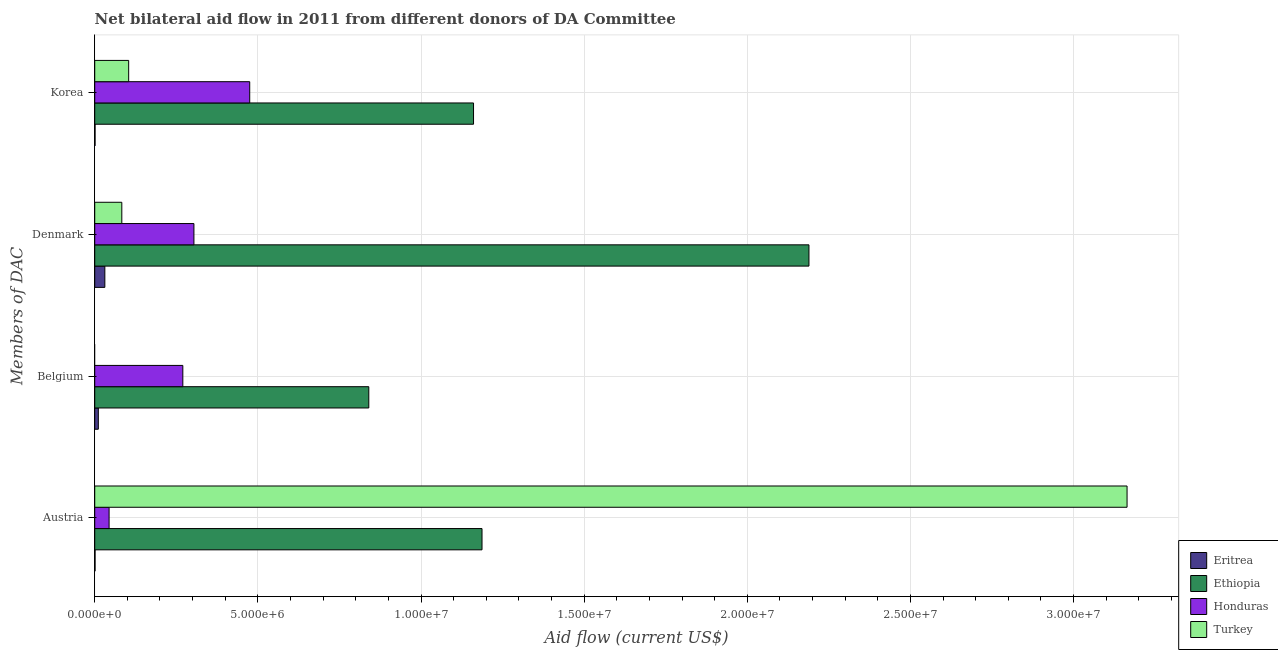How many different coloured bars are there?
Ensure brevity in your answer.  4. How many groups of bars are there?
Your answer should be compact. 4. Are the number of bars per tick equal to the number of legend labels?
Keep it short and to the point. No. How many bars are there on the 3rd tick from the bottom?
Keep it short and to the point. 4. What is the amount of aid given by austria in Eritrea?
Offer a terse response. 10000. Across all countries, what is the maximum amount of aid given by austria?
Your answer should be compact. 3.16e+07. Across all countries, what is the minimum amount of aid given by korea?
Keep it short and to the point. 10000. In which country was the amount of aid given by korea maximum?
Ensure brevity in your answer.  Ethiopia. What is the total amount of aid given by austria in the graph?
Provide a short and direct response. 4.40e+07. What is the difference between the amount of aid given by belgium in Ethiopia and that in Honduras?
Provide a succinct answer. 5.70e+06. What is the difference between the amount of aid given by belgium in Ethiopia and the amount of aid given by korea in Honduras?
Provide a short and direct response. 3.65e+06. What is the average amount of aid given by korea per country?
Make the answer very short. 4.35e+06. What is the difference between the amount of aid given by austria and amount of aid given by denmark in Ethiopia?
Your answer should be compact. -1.00e+07. What is the ratio of the amount of aid given by korea in Eritrea to that in Turkey?
Offer a very short reply. 0.01. Is the amount of aid given by korea in Eritrea less than that in Ethiopia?
Ensure brevity in your answer.  Yes. What is the difference between the highest and the second highest amount of aid given by austria?
Provide a short and direct response. 1.98e+07. What is the difference between the highest and the lowest amount of aid given by austria?
Your answer should be very brief. 3.16e+07. In how many countries, is the amount of aid given by korea greater than the average amount of aid given by korea taken over all countries?
Keep it short and to the point. 2. Is it the case that in every country, the sum of the amount of aid given by denmark and amount of aid given by belgium is greater than the sum of amount of aid given by austria and amount of aid given by korea?
Offer a terse response. No. Is it the case that in every country, the sum of the amount of aid given by austria and amount of aid given by belgium is greater than the amount of aid given by denmark?
Offer a terse response. No. How many countries are there in the graph?
Provide a short and direct response. 4. What is the difference between two consecutive major ticks on the X-axis?
Give a very brief answer. 5.00e+06. Does the graph contain grids?
Provide a short and direct response. Yes. Where does the legend appear in the graph?
Your response must be concise. Bottom right. What is the title of the graph?
Your answer should be compact. Net bilateral aid flow in 2011 from different donors of DA Committee. Does "Lithuania" appear as one of the legend labels in the graph?
Your answer should be compact. No. What is the label or title of the X-axis?
Offer a terse response. Aid flow (current US$). What is the label or title of the Y-axis?
Your answer should be compact. Members of DAC. What is the Aid flow (current US$) in Eritrea in Austria?
Keep it short and to the point. 10000. What is the Aid flow (current US$) in Ethiopia in Austria?
Offer a very short reply. 1.19e+07. What is the Aid flow (current US$) in Turkey in Austria?
Provide a succinct answer. 3.16e+07. What is the Aid flow (current US$) of Eritrea in Belgium?
Keep it short and to the point. 1.10e+05. What is the Aid flow (current US$) in Ethiopia in Belgium?
Offer a very short reply. 8.40e+06. What is the Aid flow (current US$) in Honduras in Belgium?
Give a very brief answer. 2.70e+06. What is the Aid flow (current US$) of Ethiopia in Denmark?
Make the answer very short. 2.19e+07. What is the Aid flow (current US$) of Honduras in Denmark?
Your answer should be very brief. 3.04e+06. What is the Aid flow (current US$) of Turkey in Denmark?
Make the answer very short. 8.30e+05. What is the Aid flow (current US$) in Eritrea in Korea?
Make the answer very short. 10000. What is the Aid flow (current US$) of Ethiopia in Korea?
Provide a short and direct response. 1.16e+07. What is the Aid flow (current US$) of Honduras in Korea?
Your answer should be compact. 4.75e+06. What is the Aid flow (current US$) in Turkey in Korea?
Make the answer very short. 1.04e+06. Across all Members of DAC, what is the maximum Aid flow (current US$) of Eritrea?
Ensure brevity in your answer.  3.10e+05. Across all Members of DAC, what is the maximum Aid flow (current US$) in Ethiopia?
Your answer should be very brief. 2.19e+07. Across all Members of DAC, what is the maximum Aid flow (current US$) in Honduras?
Provide a short and direct response. 4.75e+06. Across all Members of DAC, what is the maximum Aid flow (current US$) in Turkey?
Provide a succinct answer. 3.16e+07. Across all Members of DAC, what is the minimum Aid flow (current US$) in Ethiopia?
Your response must be concise. 8.40e+06. What is the total Aid flow (current US$) in Ethiopia in the graph?
Ensure brevity in your answer.  5.38e+07. What is the total Aid flow (current US$) in Honduras in the graph?
Your answer should be very brief. 1.09e+07. What is the total Aid flow (current US$) in Turkey in the graph?
Give a very brief answer. 3.35e+07. What is the difference between the Aid flow (current US$) in Ethiopia in Austria and that in Belgium?
Offer a terse response. 3.47e+06. What is the difference between the Aid flow (current US$) in Honduras in Austria and that in Belgium?
Make the answer very short. -2.26e+06. What is the difference between the Aid flow (current US$) of Ethiopia in Austria and that in Denmark?
Offer a very short reply. -1.00e+07. What is the difference between the Aid flow (current US$) of Honduras in Austria and that in Denmark?
Give a very brief answer. -2.60e+06. What is the difference between the Aid flow (current US$) in Turkey in Austria and that in Denmark?
Provide a short and direct response. 3.08e+07. What is the difference between the Aid flow (current US$) in Eritrea in Austria and that in Korea?
Your response must be concise. 0. What is the difference between the Aid flow (current US$) in Honduras in Austria and that in Korea?
Ensure brevity in your answer.  -4.31e+06. What is the difference between the Aid flow (current US$) of Turkey in Austria and that in Korea?
Provide a succinct answer. 3.06e+07. What is the difference between the Aid flow (current US$) in Eritrea in Belgium and that in Denmark?
Provide a succinct answer. -2.00e+05. What is the difference between the Aid flow (current US$) in Ethiopia in Belgium and that in Denmark?
Your answer should be compact. -1.35e+07. What is the difference between the Aid flow (current US$) in Eritrea in Belgium and that in Korea?
Your answer should be very brief. 1.00e+05. What is the difference between the Aid flow (current US$) in Ethiopia in Belgium and that in Korea?
Give a very brief answer. -3.21e+06. What is the difference between the Aid flow (current US$) of Honduras in Belgium and that in Korea?
Give a very brief answer. -2.05e+06. What is the difference between the Aid flow (current US$) of Ethiopia in Denmark and that in Korea?
Provide a succinct answer. 1.03e+07. What is the difference between the Aid flow (current US$) of Honduras in Denmark and that in Korea?
Your answer should be compact. -1.71e+06. What is the difference between the Aid flow (current US$) of Eritrea in Austria and the Aid flow (current US$) of Ethiopia in Belgium?
Provide a short and direct response. -8.39e+06. What is the difference between the Aid flow (current US$) in Eritrea in Austria and the Aid flow (current US$) in Honduras in Belgium?
Give a very brief answer. -2.69e+06. What is the difference between the Aid flow (current US$) of Ethiopia in Austria and the Aid flow (current US$) of Honduras in Belgium?
Offer a very short reply. 9.17e+06. What is the difference between the Aid flow (current US$) in Eritrea in Austria and the Aid flow (current US$) in Ethiopia in Denmark?
Make the answer very short. -2.19e+07. What is the difference between the Aid flow (current US$) of Eritrea in Austria and the Aid flow (current US$) of Honduras in Denmark?
Keep it short and to the point. -3.03e+06. What is the difference between the Aid flow (current US$) in Eritrea in Austria and the Aid flow (current US$) in Turkey in Denmark?
Make the answer very short. -8.20e+05. What is the difference between the Aid flow (current US$) of Ethiopia in Austria and the Aid flow (current US$) of Honduras in Denmark?
Offer a very short reply. 8.83e+06. What is the difference between the Aid flow (current US$) of Ethiopia in Austria and the Aid flow (current US$) of Turkey in Denmark?
Keep it short and to the point. 1.10e+07. What is the difference between the Aid flow (current US$) in Honduras in Austria and the Aid flow (current US$) in Turkey in Denmark?
Keep it short and to the point. -3.90e+05. What is the difference between the Aid flow (current US$) of Eritrea in Austria and the Aid flow (current US$) of Ethiopia in Korea?
Keep it short and to the point. -1.16e+07. What is the difference between the Aid flow (current US$) of Eritrea in Austria and the Aid flow (current US$) of Honduras in Korea?
Keep it short and to the point. -4.74e+06. What is the difference between the Aid flow (current US$) of Eritrea in Austria and the Aid flow (current US$) of Turkey in Korea?
Offer a terse response. -1.03e+06. What is the difference between the Aid flow (current US$) of Ethiopia in Austria and the Aid flow (current US$) of Honduras in Korea?
Keep it short and to the point. 7.12e+06. What is the difference between the Aid flow (current US$) of Ethiopia in Austria and the Aid flow (current US$) of Turkey in Korea?
Your response must be concise. 1.08e+07. What is the difference between the Aid flow (current US$) in Honduras in Austria and the Aid flow (current US$) in Turkey in Korea?
Provide a short and direct response. -6.00e+05. What is the difference between the Aid flow (current US$) of Eritrea in Belgium and the Aid flow (current US$) of Ethiopia in Denmark?
Give a very brief answer. -2.18e+07. What is the difference between the Aid flow (current US$) in Eritrea in Belgium and the Aid flow (current US$) in Honduras in Denmark?
Your response must be concise. -2.93e+06. What is the difference between the Aid flow (current US$) in Eritrea in Belgium and the Aid flow (current US$) in Turkey in Denmark?
Your answer should be compact. -7.20e+05. What is the difference between the Aid flow (current US$) of Ethiopia in Belgium and the Aid flow (current US$) of Honduras in Denmark?
Keep it short and to the point. 5.36e+06. What is the difference between the Aid flow (current US$) in Ethiopia in Belgium and the Aid flow (current US$) in Turkey in Denmark?
Give a very brief answer. 7.57e+06. What is the difference between the Aid flow (current US$) in Honduras in Belgium and the Aid flow (current US$) in Turkey in Denmark?
Offer a terse response. 1.87e+06. What is the difference between the Aid flow (current US$) in Eritrea in Belgium and the Aid flow (current US$) in Ethiopia in Korea?
Your answer should be compact. -1.15e+07. What is the difference between the Aid flow (current US$) of Eritrea in Belgium and the Aid flow (current US$) of Honduras in Korea?
Ensure brevity in your answer.  -4.64e+06. What is the difference between the Aid flow (current US$) in Eritrea in Belgium and the Aid flow (current US$) in Turkey in Korea?
Make the answer very short. -9.30e+05. What is the difference between the Aid flow (current US$) in Ethiopia in Belgium and the Aid flow (current US$) in Honduras in Korea?
Your answer should be compact. 3.65e+06. What is the difference between the Aid flow (current US$) in Ethiopia in Belgium and the Aid flow (current US$) in Turkey in Korea?
Offer a very short reply. 7.36e+06. What is the difference between the Aid flow (current US$) of Honduras in Belgium and the Aid flow (current US$) of Turkey in Korea?
Your answer should be compact. 1.66e+06. What is the difference between the Aid flow (current US$) of Eritrea in Denmark and the Aid flow (current US$) of Ethiopia in Korea?
Your answer should be compact. -1.13e+07. What is the difference between the Aid flow (current US$) of Eritrea in Denmark and the Aid flow (current US$) of Honduras in Korea?
Provide a succinct answer. -4.44e+06. What is the difference between the Aid flow (current US$) of Eritrea in Denmark and the Aid flow (current US$) of Turkey in Korea?
Offer a terse response. -7.30e+05. What is the difference between the Aid flow (current US$) of Ethiopia in Denmark and the Aid flow (current US$) of Honduras in Korea?
Your response must be concise. 1.71e+07. What is the difference between the Aid flow (current US$) in Ethiopia in Denmark and the Aid flow (current US$) in Turkey in Korea?
Offer a very short reply. 2.08e+07. What is the average Aid flow (current US$) of Eritrea per Members of DAC?
Offer a very short reply. 1.10e+05. What is the average Aid flow (current US$) of Ethiopia per Members of DAC?
Your answer should be very brief. 1.34e+07. What is the average Aid flow (current US$) in Honduras per Members of DAC?
Offer a terse response. 2.73e+06. What is the average Aid flow (current US$) in Turkey per Members of DAC?
Offer a very short reply. 8.38e+06. What is the difference between the Aid flow (current US$) in Eritrea and Aid flow (current US$) in Ethiopia in Austria?
Ensure brevity in your answer.  -1.19e+07. What is the difference between the Aid flow (current US$) in Eritrea and Aid flow (current US$) in Honduras in Austria?
Offer a very short reply. -4.30e+05. What is the difference between the Aid flow (current US$) of Eritrea and Aid flow (current US$) of Turkey in Austria?
Ensure brevity in your answer.  -3.16e+07. What is the difference between the Aid flow (current US$) of Ethiopia and Aid flow (current US$) of Honduras in Austria?
Your answer should be very brief. 1.14e+07. What is the difference between the Aid flow (current US$) of Ethiopia and Aid flow (current US$) of Turkey in Austria?
Your answer should be very brief. -1.98e+07. What is the difference between the Aid flow (current US$) of Honduras and Aid flow (current US$) of Turkey in Austria?
Your answer should be very brief. -3.12e+07. What is the difference between the Aid flow (current US$) of Eritrea and Aid flow (current US$) of Ethiopia in Belgium?
Your response must be concise. -8.29e+06. What is the difference between the Aid flow (current US$) of Eritrea and Aid flow (current US$) of Honduras in Belgium?
Your answer should be compact. -2.59e+06. What is the difference between the Aid flow (current US$) in Ethiopia and Aid flow (current US$) in Honduras in Belgium?
Give a very brief answer. 5.70e+06. What is the difference between the Aid flow (current US$) of Eritrea and Aid flow (current US$) of Ethiopia in Denmark?
Make the answer very short. -2.16e+07. What is the difference between the Aid flow (current US$) in Eritrea and Aid flow (current US$) in Honduras in Denmark?
Offer a terse response. -2.73e+06. What is the difference between the Aid flow (current US$) in Eritrea and Aid flow (current US$) in Turkey in Denmark?
Keep it short and to the point. -5.20e+05. What is the difference between the Aid flow (current US$) in Ethiopia and Aid flow (current US$) in Honduras in Denmark?
Give a very brief answer. 1.88e+07. What is the difference between the Aid flow (current US$) in Ethiopia and Aid flow (current US$) in Turkey in Denmark?
Keep it short and to the point. 2.11e+07. What is the difference between the Aid flow (current US$) in Honduras and Aid flow (current US$) in Turkey in Denmark?
Offer a terse response. 2.21e+06. What is the difference between the Aid flow (current US$) in Eritrea and Aid flow (current US$) in Ethiopia in Korea?
Ensure brevity in your answer.  -1.16e+07. What is the difference between the Aid flow (current US$) of Eritrea and Aid flow (current US$) of Honduras in Korea?
Offer a very short reply. -4.74e+06. What is the difference between the Aid flow (current US$) in Eritrea and Aid flow (current US$) in Turkey in Korea?
Make the answer very short. -1.03e+06. What is the difference between the Aid flow (current US$) in Ethiopia and Aid flow (current US$) in Honduras in Korea?
Give a very brief answer. 6.86e+06. What is the difference between the Aid flow (current US$) of Ethiopia and Aid flow (current US$) of Turkey in Korea?
Offer a terse response. 1.06e+07. What is the difference between the Aid flow (current US$) of Honduras and Aid flow (current US$) of Turkey in Korea?
Offer a terse response. 3.71e+06. What is the ratio of the Aid flow (current US$) of Eritrea in Austria to that in Belgium?
Provide a succinct answer. 0.09. What is the ratio of the Aid flow (current US$) of Ethiopia in Austria to that in Belgium?
Make the answer very short. 1.41. What is the ratio of the Aid flow (current US$) of Honduras in Austria to that in Belgium?
Your answer should be compact. 0.16. What is the ratio of the Aid flow (current US$) in Eritrea in Austria to that in Denmark?
Your response must be concise. 0.03. What is the ratio of the Aid flow (current US$) in Ethiopia in Austria to that in Denmark?
Your answer should be very brief. 0.54. What is the ratio of the Aid flow (current US$) of Honduras in Austria to that in Denmark?
Ensure brevity in your answer.  0.14. What is the ratio of the Aid flow (current US$) in Turkey in Austria to that in Denmark?
Keep it short and to the point. 38.12. What is the ratio of the Aid flow (current US$) in Ethiopia in Austria to that in Korea?
Provide a succinct answer. 1.02. What is the ratio of the Aid flow (current US$) in Honduras in Austria to that in Korea?
Your answer should be very brief. 0.09. What is the ratio of the Aid flow (current US$) of Turkey in Austria to that in Korea?
Provide a short and direct response. 30.42. What is the ratio of the Aid flow (current US$) of Eritrea in Belgium to that in Denmark?
Your answer should be compact. 0.35. What is the ratio of the Aid flow (current US$) in Ethiopia in Belgium to that in Denmark?
Your answer should be compact. 0.38. What is the ratio of the Aid flow (current US$) in Honduras in Belgium to that in Denmark?
Make the answer very short. 0.89. What is the ratio of the Aid flow (current US$) in Ethiopia in Belgium to that in Korea?
Give a very brief answer. 0.72. What is the ratio of the Aid flow (current US$) in Honduras in Belgium to that in Korea?
Your answer should be compact. 0.57. What is the ratio of the Aid flow (current US$) of Eritrea in Denmark to that in Korea?
Make the answer very short. 31. What is the ratio of the Aid flow (current US$) of Ethiopia in Denmark to that in Korea?
Your response must be concise. 1.89. What is the ratio of the Aid flow (current US$) in Honduras in Denmark to that in Korea?
Offer a terse response. 0.64. What is the ratio of the Aid flow (current US$) of Turkey in Denmark to that in Korea?
Make the answer very short. 0.8. What is the difference between the highest and the second highest Aid flow (current US$) of Ethiopia?
Provide a short and direct response. 1.00e+07. What is the difference between the highest and the second highest Aid flow (current US$) of Honduras?
Make the answer very short. 1.71e+06. What is the difference between the highest and the second highest Aid flow (current US$) in Turkey?
Provide a succinct answer. 3.06e+07. What is the difference between the highest and the lowest Aid flow (current US$) in Eritrea?
Provide a short and direct response. 3.00e+05. What is the difference between the highest and the lowest Aid flow (current US$) of Ethiopia?
Provide a short and direct response. 1.35e+07. What is the difference between the highest and the lowest Aid flow (current US$) of Honduras?
Provide a succinct answer. 4.31e+06. What is the difference between the highest and the lowest Aid flow (current US$) of Turkey?
Give a very brief answer. 3.16e+07. 